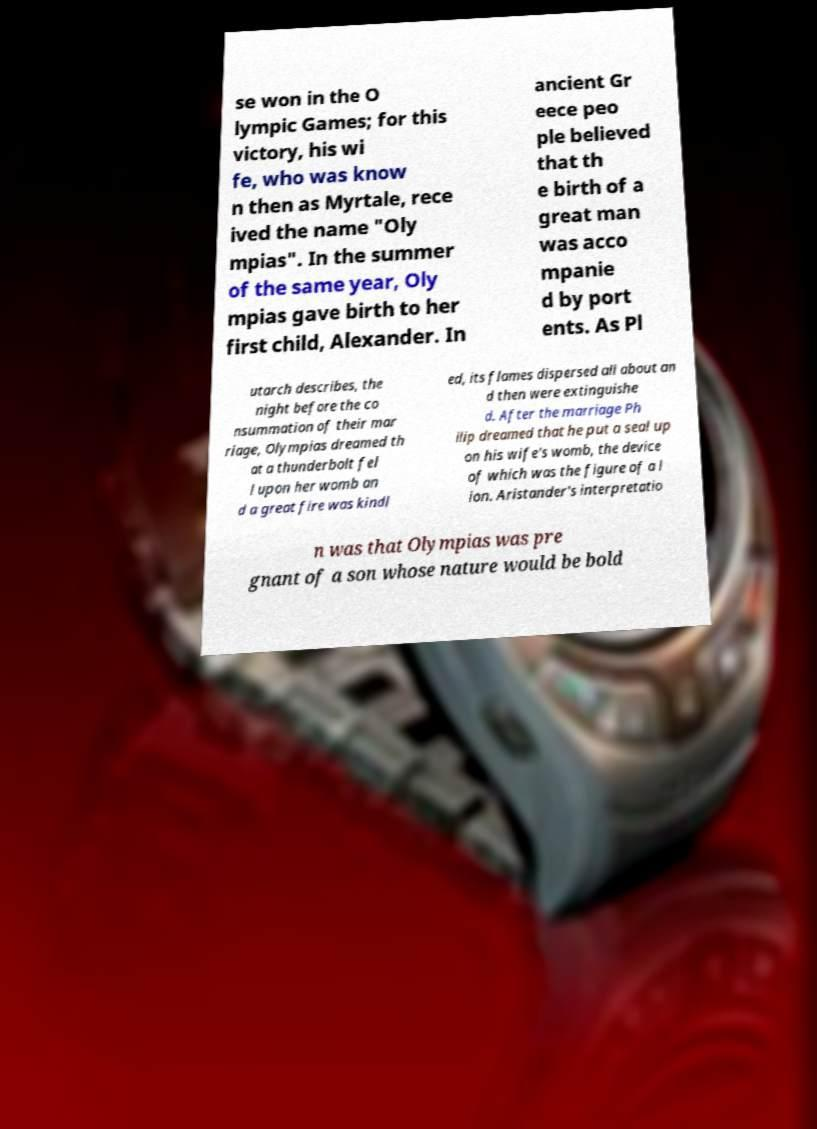I need the written content from this picture converted into text. Can you do that? se won in the O lympic Games; for this victory, his wi fe, who was know n then as Myrtale, rece ived the name "Oly mpias". In the summer of the same year, Oly mpias gave birth to her first child, Alexander. In ancient Gr eece peo ple believed that th e birth of a great man was acco mpanie d by port ents. As Pl utarch describes, the night before the co nsummation of their mar riage, Olympias dreamed th at a thunderbolt fel l upon her womb an d a great fire was kindl ed, its flames dispersed all about an d then were extinguishe d. After the marriage Ph ilip dreamed that he put a seal up on his wife's womb, the device of which was the figure of a l ion. Aristander's interpretatio n was that Olympias was pre gnant of a son whose nature would be bold 